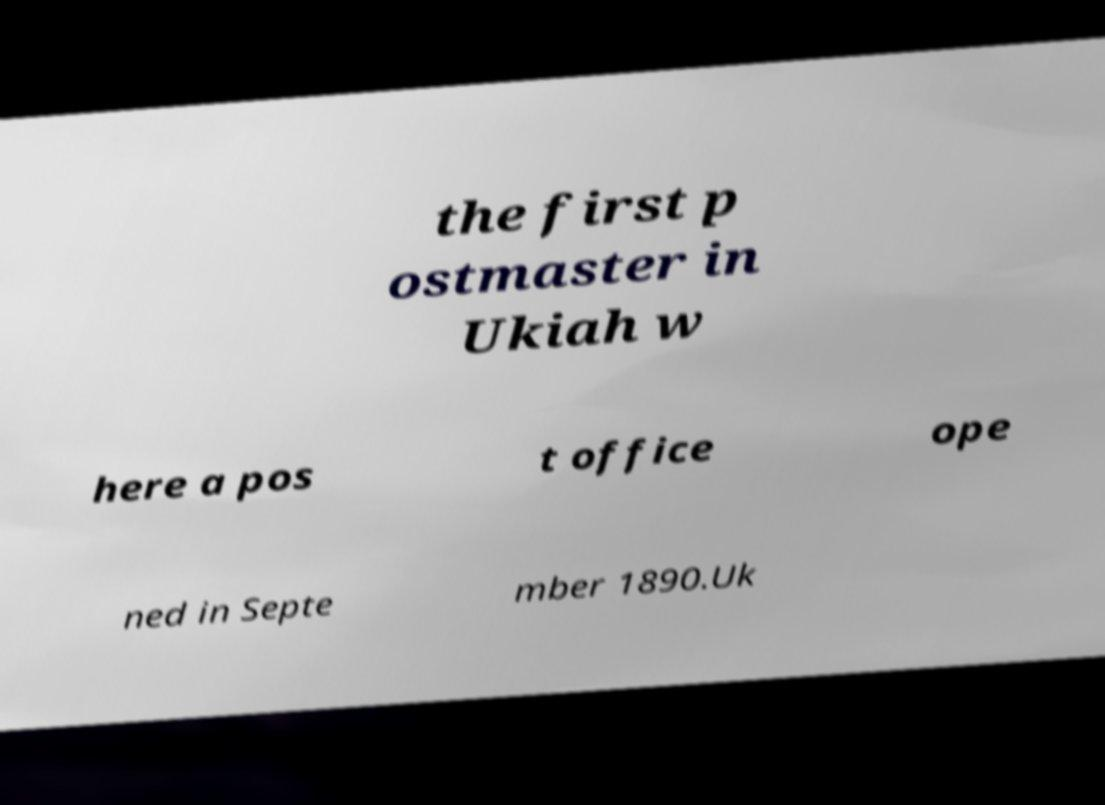For documentation purposes, I need the text within this image transcribed. Could you provide that? the first p ostmaster in Ukiah w here a pos t office ope ned in Septe mber 1890.Uk 